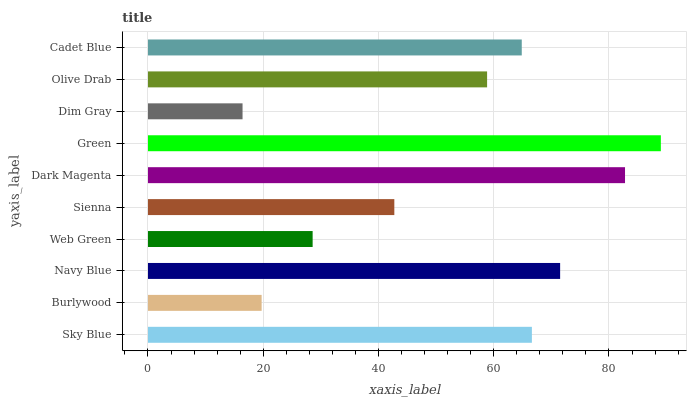Is Dim Gray the minimum?
Answer yes or no. Yes. Is Green the maximum?
Answer yes or no. Yes. Is Burlywood the minimum?
Answer yes or no. No. Is Burlywood the maximum?
Answer yes or no. No. Is Sky Blue greater than Burlywood?
Answer yes or no. Yes. Is Burlywood less than Sky Blue?
Answer yes or no. Yes. Is Burlywood greater than Sky Blue?
Answer yes or no. No. Is Sky Blue less than Burlywood?
Answer yes or no. No. Is Cadet Blue the high median?
Answer yes or no. Yes. Is Olive Drab the low median?
Answer yes or no. Yes. Is Dim Gray the high median?
Answer yes or no. No. Is Dim Gray the low median?
Answer yes or no. No. 